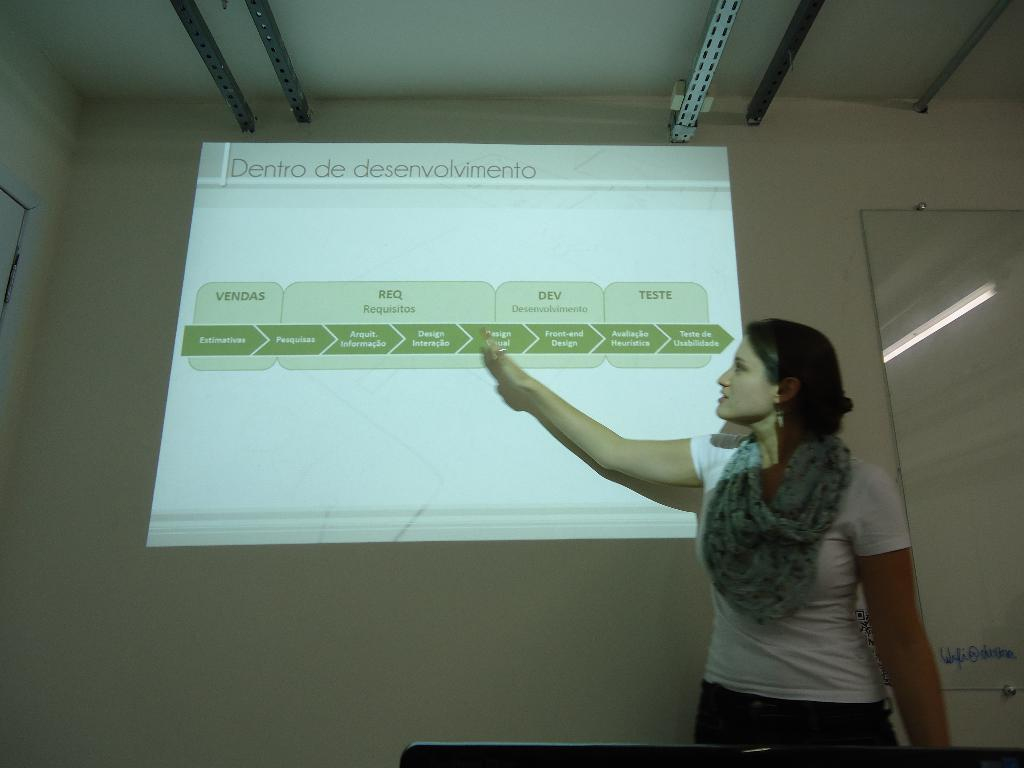<image>
Relay a brief, clear account of the picture shown. A woman points to a screen projected on the wall that is titled Dentro de desenvolvimento. 